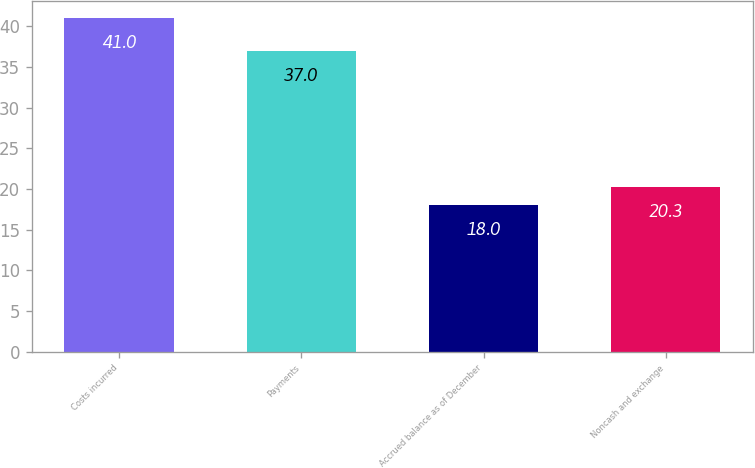Convert chart. <chart><loc_0><loc_0><loc_500><loc_500><bar_chart><fcel>Costs incurred<fcel>Payments<fcel>Accrued balance as of December<fcel>Noncash and exchange<nl><fcel>41<fcel>37<fcel>18<fcel>20.3<nl></chart> 